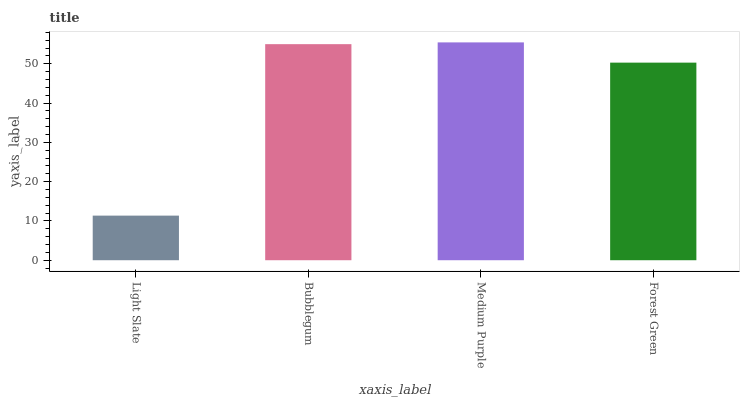Is Light Slate the minimum?
Answer yes or no. Yes. Is Medium Purple the maximum?
Answer yes or no. Yes. Is Bubblegum the minimum?
Answer yes or no. No. Is Bubblegum the maximum?
Answer yes or no. No. Is Bubblegum greater than Light Slate?
Answer yes or no. Yes. Is Light Slate less than Bubblegum?
Answer yes or no. Yes. Is Light Slate greater than Bubblegum?
Answer yes or no. No. Is Bubblegum less than Light Slate?
Answer yes or no. No. Is Bubblegum the high median?
Answer yes or no. Yes. Is Forest Green the low median?
Answer yes or no. Yes. Is Medium Purple the high median?
Answer yes or no. No. Is Medium Purple the low median?
Answer yes or no. No. 